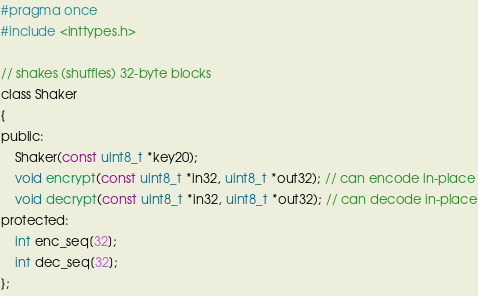Convert code to text. <code><loc_0><loc_0><loc_500><loc_500><_C_>#pragma once
#include <inttypes.h>

// shakes (shuffles) 32-byte blocks
class Shaker
{
public:
	Shaker(const uint8_t *key20);
	void encrypt(const uint8_t *in32, uint8_t *out32); // can encode in-place
	void decrypt(const uint8_t *in32, uint8_t *out32); // can decode in-place
protected:
	int enc_seq[32];
	int dec_seq[32];
};

</code> 